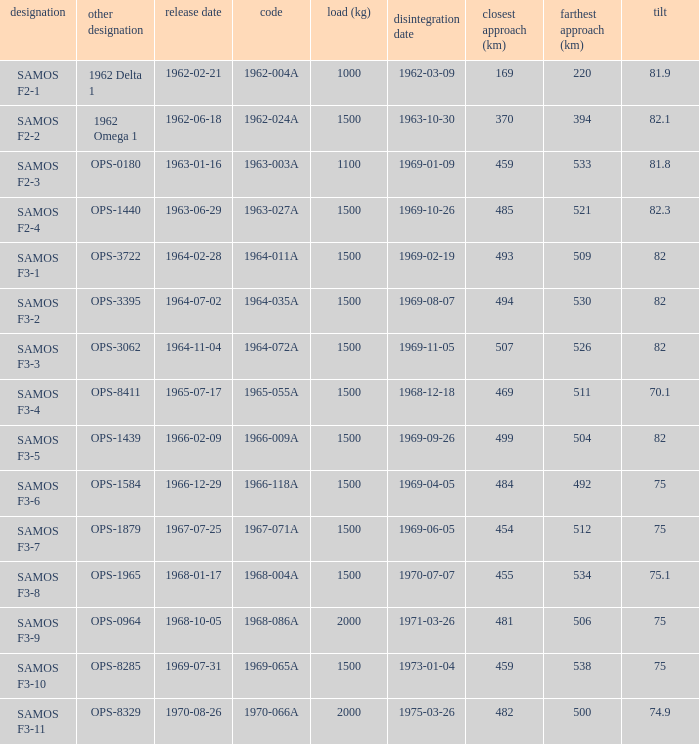Help me parse the entirety of this table. {'header': ['designation', 'other designation', 'release date', 'code', 'load (kg)', 'disintegration date', 'closest approach (km)', 'farthest approach (km)', 'tilt'], 'rows': [['SAMOS F2-1', '1962 Delta 1', '1962-02-21', '1962-004A', '1000', '1962-03-09', '169', '220', '81.9'], ['SAMOS F2-2', '1962 Omega 1', '1962-06-18', '1962-024A', '1500', '1963-10-30', '370', '394', '82.1'], ['SAMOS F2-3', 'OPS-0180', '1963-01-16', '1963-003A', '1100', '1969-01-09', '459', '533', '81.8'], ['SAMOS F2-4', 'OPS-1440', '1963-06-29', '1963-027A', '1500', '1969-10-26', '485', '521', '82.3'], ['SAMOS F3-1', 'OPS-3722', '1964-02-28', '1964-011A', '1500', '1969-02-19', '493', '509', '82'], ['SAMOS F3-2', 'OPS-3395', '1964-07-02', '1964-035A', '1500', '1969-08-07', '494', '530', '82'], ['SAMOS F3-3', 'OPS-3062', '1964-11-04', '1964-072A', '1500', '1969-11-05', '507', '526', '82'], ['SAMOS F3-4', 'OPS-8411', '1965-07-17', '1965-055A', '1500', '1968-12-18', '469', '511', '70.1'], ['SAMOS F3-5', 'OPS-1439', '1966-02-09', '1966-009A', '1500', '1969-09-26', '499', '504', '82'], ['SAMOS F3-6', 'OPS-1584', '1966-12-29', '1966-118A', '1500', '1969-04-05', '484', '492', '75'], ['SAMOS F3-7', 'OPS-1879', '1967-07-25', '1967-071A', '1500', '1969-06-05', '454', '512', '75'], ['SAMOS F3-8', 'OPS-1965', '1968-01-17', '1968-004A', '1500', '1970-07-07', '455', '534', '75.1'], ['SAMOS F3-9', 'OPS-0964', '1968-10-05', '1968-086A', '2000', '1971-03-26', '481', '506', '75'], ['SAMOS F3-10', 'OPS-8285', '1969-07-31', '1969-065A', '1500', '1973-01-04', '459', '538', '75'], ['SAMOS F3-11', 'OPS-8329', '1970-08-26', '1970-066A', '2000', '1975-03-26', '482', '500', '74.9']]} What is the inclination when the alt name is OPS-1584? 75.0. 